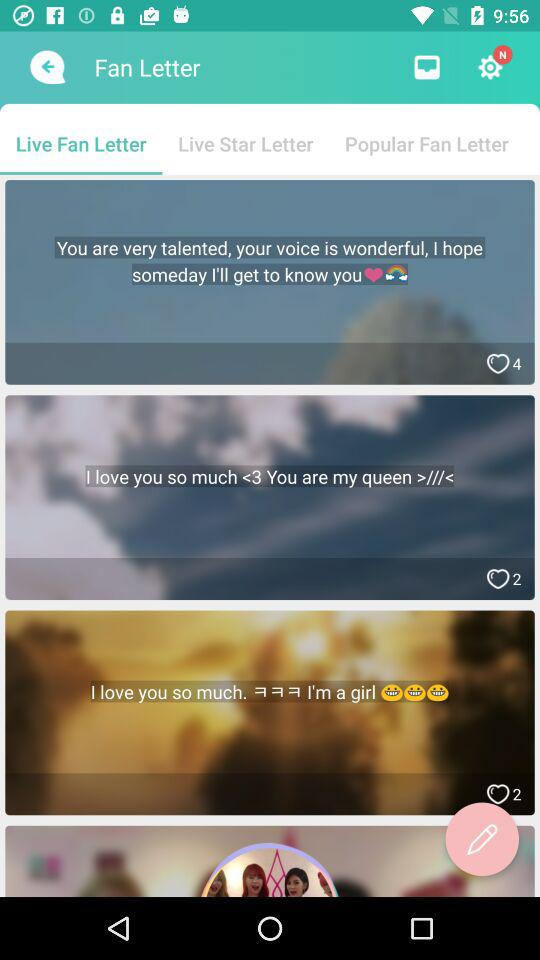Which is the currently selected tab? The currently selected tab is "Live Fan Letter". 